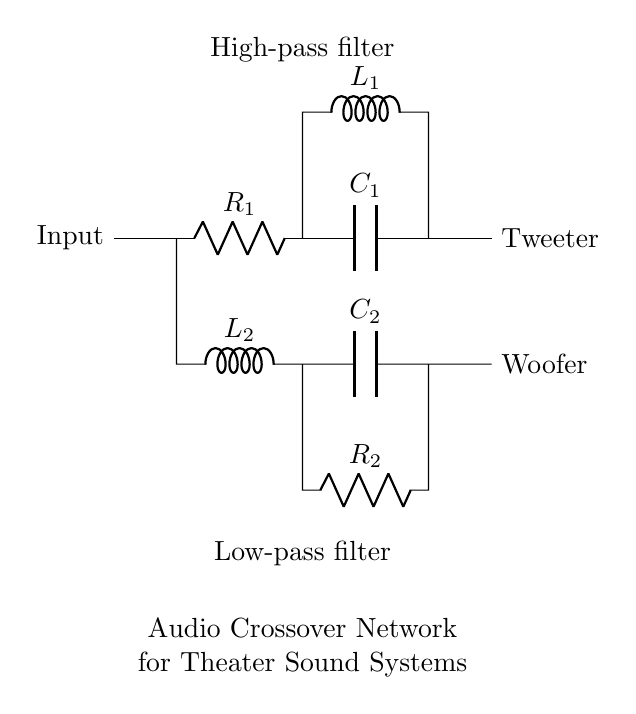what type of filters are used in this audio crossover network? The circuit diagram consists of a high-pass filter and a low-pass filter, clearly labeled in the diagram. These filters allow certain frequency ranges to pass through while blocking others, which is essential in audio systems to separate sounds for different speakers.
Answer: high-pass and low-pass how many resistors are present in the circuit? There are two resistors labeled R1 and R2 in the circuit diagram. They are clearly indicated and positioned in their respective filters.
Answer: two what is the role of the capacitor in the high-pass filter? The capacitor, labeled C1 in the high-pass filter, blocks low-frequency signals while allowing high-frequency signals to pass through to the tweeter. Capacitors in such configurations are essential for producing clear high-frequency sound.
Answer: blocks low frequencies which component is used to connect to the tweeter? The high-pass filter, which connects through its output, is directly leading to the tweeter, indicated in the circuit. This configuration is designed to send high frequencies to the tweeter for better sound quality.
Answer: high-pass filter how does the low-pass filter affect the woofer's sound output? The low-pass filter, which includes inductor L2 and capacitor C2, allows low-frequency signals to pass while blocking high-frequency signals. This filtering ensures that only bass sounds are delivered to the woofer, providing a richer sound experience.
Answer: allows low frequencies what components are used in the low-pass filter? The low-pass filter comprises one inductor (L2) and one capacitor (C2), along with a resistor (R2). These components work together to filter sound for low frequencies, specifically directing them to the woofer.
Answer: inductor, capacitor, resistor what is the purpose of the audio crossover network? The audio crossover network is designed to split audio signals into different frequency ranges to distribute them appropriately to various speakers, such as woofers and tweeters, enhancing audio quality in theater sound systems.
Answer: split audio signals 